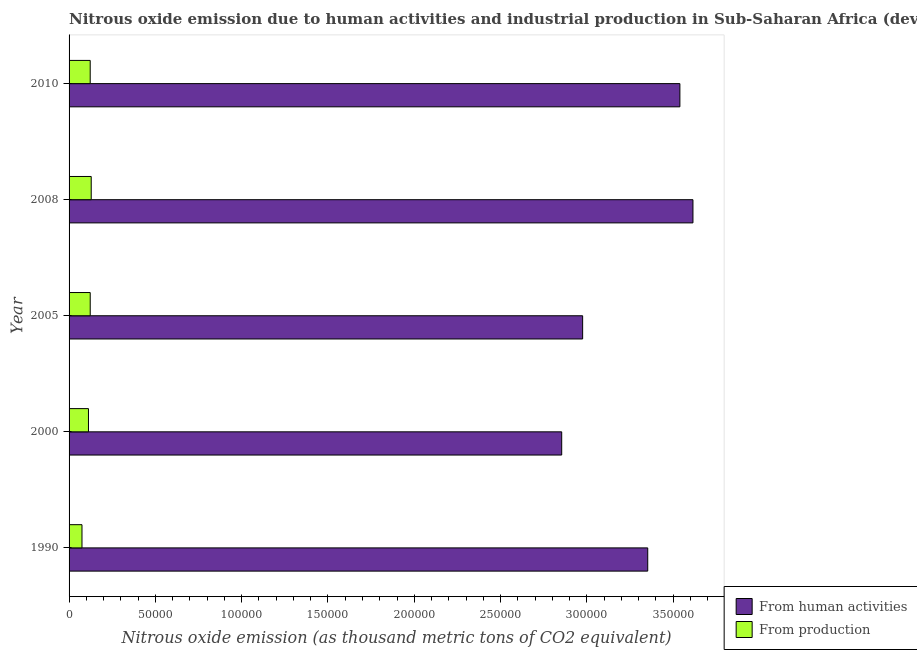Are the number of bars per tick equal to the number of legend labels?
Ensure brevity in your answer.  Yes. Are the number of bars on each tick of the Y-axis equal?
Your answer should be very brief. Yes. How many bars are there on the 5th tick from the bottom?
Your response must be concise. 2. What is the label of the 3rd group of bars from the top?
Offer a terse response. 2005. In how many cases, is the number of bars for a given year not equal to the number of legend labels?
Provide a succinct answer. 0. What is the amount of emissions generated from industries in 2005?
Keep it short and to the point. 1.23e+04. Across all years, what is the maximum amount of emissions generated from industries?
Your response must be concise. 1.28e+04. Across all years, what is the minimum amount of emissions generated from industries?
Your answer should be very brief. 7482.3. In which year was the amount of emissions from human activities maximum?
Give a very brief answer. 2008. What is the total amount of emissions from human activities in the graph?
Your answer should be very brief. 1.63e+06. What is the difference between the amount of emissions generated from industries in 2000 and that in 2008?
Provide a short and direct response. -1594.7. What is the difference between the amount of emissions from human activities in 2008 and the amount of emissions generated from industries in 1990?
Your response must be concise. 3.54e+05. What is the average amount of emissions from human activities per year?
Give a very brief answer. 3.27e+05. In the year 1990, what is the difference between the amount of emissions from human activities and amount of emissions generated from industries?
Your response must be concise. 3.28e+05. In how many years, is the amount of emissions from human activities greater than 250000 thousand metric tons?
Keep it short and to the point. 5. What is the ratio of the amount of emissions from human activities in 2000 to that in 2010?
Your answer should be compact. 0.81. Is the difference between the amount of emissions from human activities in 2000 and 2005 greater than the difference between the amount of emissions generated from industries in 2000 and 2005?
Provide a short and direct response. No. What is the difference between the highest and the second highest amount of emissions from human activities?
Offer a terse response. 7568.3. What is the difference between the highest and the lowest amount of emissions from human activities?
Your response must be concise. 7.60e+04. In how many years, is the amount of emissions from human activities greater than the average amount of emissions from human activities taken over all years?
Provide a short and direct response. 3. What does the 1st bar from the top in 2010 represents?
Keep it short and to the point. From production. What does the 2nd bar from the bottom in 2008 represents?
Your response must be concise. From production. Are the values on the major ticks of X-axis written in scientific E-notation?
Provide a succinct answer. No. Where does the legend appear in the graph?
Offer a very short reply. Bottom right. What is the title of the graph?
Provide a short and direct response. Nitrous oxide emission due to human activities and industrial production in Sub-Saharan Africa (developing only). What is the label or title of the X-axis?
Give a very brief answer. Nitrous oxide emission (as thousand metric tons of CO2 equivalent). What is the Nitrous oxide emission (as thousand metric tons of CO2 equivalent) of From human activities in 1990?
Provide a short and direct response. 3.35e+05. What is the Nitrous oxide emission (as thousand metric tons of CO2 equivalent) of From production in 1990?
Offer a terse response. 7482.3. What is the Nitrous oxide emission (as thousand metric tons of CO2 equivalent) in From human activities in 2000?
Keep it short and to the point. 2.85e+05. What is the Nitrous oxide emission (as thousand metric tons of CO2 equivalent) of From production in 2000?
Provide a short and direct response. 1.12e+04. What is the Nitrous oxide emission (as thousand metric tons of CO2 equivalent) in From human activities in 2005?
Your answer should be very brief. 2.98e+05. What is the Nitrous oxide emission (as thousand metric tons of CO2 equivalent) in From production in 2005?
Provide a short and direct response. 1.23e+04. What is the Nitrous oxide emission (as thousand metric tons of CO2 equivalent) of From human activities in 2008?
Offer a terse response. 3.61e+05. What is the Nitrous oxide emission (as thousand metric tons of CO2 equivalent) in From production in 2008?
Offer a terse response. 1.28e+04. What is the Nitrous oxide emission (as thousand metric tons of CO2 equivalent) in From human activities in 2010?
Offer a terse response. 3.54e+05. What is the Nitrous oxide emission (as thousand metric tons of CO2 equivalent) of From production in 2010?
Provide a succinct answer. 1.22e+04. Across all years, what is the maximum Nitrous oxide emission (as thousand metric tons of CO2 equivalent) in From human activities?
Ensure brevity in your answer.  3.61e+05. Across all years, what is the maximum Nitrous oxide emission (as thousand metric tons of CO2 equivalent) of From production?
Offer a very short reply. 1.28e+04. Across all years, what is the minimum Nitrous oxide emission (as thousand metric tons of CO2 equivalent) in From human activities?
Make the answer very short. 2.85e+05. Across all years, what is the minimum Nitrous oxide emission (as thousand metric tons of CO2 equivalent) in From production?
Keep it short and to the point. 7482.3. What is the total Nitrous oxide emission (as thousand metric tons of CO2 equivalent) of From human activities in the graph?
Your answer should be very brief. 1.63e+06. What is the total Nitrous oxide emission (as thousand metric tons of CO2 equivalent) of From production in the graph?
Give a very brief answer. 5.61e+04. What is the difference between the Nitrous oxide emission (as thousand metric tons of CO2 equivalent) in From human activities in 1990 and that in 2000?
Ensure brevity in your answer.  4.98e+04. What is the difference between the Nitrous oxide emission (as thousand metric tons of CO2 equivalent) of From production in 1990 and that in 2000?
Offer a very short reply. -3756.4. What is the difference between the Nitrous oxide emission (as thousand metric tons of CO2 equivalent) in From human activities in 1990 and that in 2005?
Give a very brief answer. 3.77e+04. What is the difference between the Nitrous oxide emission (as thousand metric tons of CO2 equivalent) of From production in 1990 and that in 2005?
Offer a very short reply. -4774.5. What is the difference between the Nitrous oxide emission (as thousand metric tons of CO2 equivalent) in From human activities in 1990 and that in 2008?
Your response must be concise. -2.62e+04. What is the difference between the Nitrous oxide emission (as thousand metric tons of CO2 equivalent) in From production in 1990 and that in 2008?
Keep it short and to the point. -5351.1. What is the difference between the Nitrous oxide emission (as thousand metric tons of CO2 equivalent) of From human activities in 1990 and that in 2010?
Offer a terse response. -1.86e+04. What is the difference between the Nitrous oxide emission (as thousand metric tons of CO2 equivalent) in From production in 1990 and that in 2010?
Your answer should be very brief. -4759.9. What is the difference between the Nitrous oxide emission (as thousand metric tons of CO2 equivalent) of From human activities in 2000 and that in 2005?
Your response must be concise. -1.21e+04. What is the difference between the Nitrous oxide emission (as thousand metric tons of CO2 equivalent) of From production in 2000 and that in 2005?
Ensure brevity in your answer.  -1018.1. What is the difference between the Nitrous oxide emission (as thousand metric tons of CO2 equivalent) of From human activities in 2000 and that in 2008?
Keep it short and to the point. -7.60e+04. What is the difference between the Nitrous oxide emission (as thousand metric tons of CO2 equivalent) in From production in 2000 and that in 2008?
Give a very brief answer. -1594.7. What is the difference between the Nitrous oxide emission (as thousand metric tons of CO2 equivalent) in From human activities in 2000 and that in 2010?
Make the answer very short. -6.85e+04. What is the difference between the Nitrous oxide emission (as thousand metric tons of CO2 equivalent) in From production in 2000 and that in 2010?
Provide a succinct answer. -1003.5. What is the difference between the Nitrous oxide emission (as thousand metric tons of CO2 equivalent) of From human activities in 2005 and that in 2008?
Your response must be concise. -6.39e+04. What is the difference between the Nitrous oxide emission (as thousand metric tons of CO2 equivalent) in From production in 2005 and that in 2008?
Provide a succinct answer. -576.6. What is the difference between the Nitrous oxide emission (as thousand metric tons of CO2 equivalent) in From human activities in 2005 and that in 2010?
Give a very brief answer. -5.63e+04. What is the difference between the Nitrous oxide emission (as thousand metric tons of CO2 equivalent) of From human activities in 2008 and that in 2010?
Provide a succinct answer. 7568.3. What is the difference between the Nitrous oxide emission (as thousand metric tons of CO2 equivalent) in From production in 2008 and that in 2010?
Your answer should be compact. 591.2. What is the difference between the Nitrous oxide emission (as thousand metric tons of CO2 equivalent) of From human activities in 1990 and the Nitrous oxide emission (as thousand metric tons of CO2 equivalent) of From production in 2000?
Offer a terse response. 3.24e+05. What is the difference between the Nitrous oxide emission (as thousand metric tons of CO2 equivalent) of From human activities in 1990 and the Nitrous oxide emission (as thousand metric tons of CO2 equivalent) of From production in 2005?
Give a very brief answer. 3.23e+05. What is the difference between the Nitrous oxide emission (as thousand metric tons of CO2 equivalent) of From human activities in 1990 and the Nitrous oxide emission (as thousand metric tons of CO2 equivalent) of From production in 2008?
Make the answer very short. 3.22e+05. What is the difference between the Nitrous oxide emission (as thousand metric tons of CO2 equivalent) in From human activities in 1990 and the Nitrous oxide emission (as thousand metric tons of CO2 equivalent) in From production in 2010?
Give a very brief answer. 3.23e+05. What is the difference between the Nitrous oxide emission (as thousand metric tons of CO2 equivalent) in From human activities in 2000 and the Nitrous oxide emission (as thousand metric tons of CO2 equivalent) in From production in 2005?
Your answer should be compact. 2.73e+05. What is the difference between the Nitrous oxide emission (as thousand metric tons of CO2 equivalent) in From human activities in 2000 and the Nitrous oxide emission (as thousand metric tons of CO2 equivalent) in From production in 2008?
Offer a terse response. 2.73e+05. What is the difference between the Nitrous oxide emission (as thousand metric tons of CO2 equivalent) of From human activities in 2000 and the Nitrous oxide emission (as thousand metric tons of CO2 equivalent) of From production in 2010?
Your response must be concise. 2.73e+05. What is the difference between the Nitrous oxide emission (as thousand metric tons of CO2 equivalent) in From human activities in 2005 and the Nitrous oxide emission (as thousand metric tons of CO2 equivalent) in From production in 2008?
Offer a terse response. 2.85e+05. What is the difference between the Nitrous oxide emission (as thousand metric tons of CO2 equivalent) in From human activities in 2005 and the Nitrous oxide emission (as thousand metric tons of CO2 equivalent) in From production in 2010?
Your response must be concise. 2.85e+05. What is the difference between the Nitrous oxide emission (as thousand metric tons of CO2 equivalent) of From human activities in 2008 and the Nitrous oxide emission (as thousand metric tons of CO2 equivalent) of From production in 2010?
Provide a succinct answer. 3.49e+05. What is the average Nitrous oxide emission (as thousand metric tons of CO2 equivalent) of From human activities per year?
Your answer should be very brief. 3.27e+05. What is the average Nitrous oxide emission (as thousand metric tons of CO2 equivalent) of From production per year?
Make the answer very short. 1.12e+04. In the year 1990, what is the difference between the Nitrous oxide emission (as thousand metric tons of CO2 equivalent) in From human activities and Nitrous oxide emission (as thousand metric tons of CO2 equivalent) in From production?
Offer a terse response. 3.28e+05. In the year 2000, what is the difference between the Nitrous oxide emission (as thousand metric tons of CO2 equivalent) in From human activities and Nitrous oxide emission (as thousand metric tons of CO2 equivalent) in From production?
Provide a succinct answer. 2.74e+05. In the year 2005, what is the difference between the Nitrous oxide emission (as thousand metric tons of CO2 equivalent) of From human activities and Nitrous oxide emission (as thousand metric tons of CO2 equivalent) of From production?
Your answer should be compact. 2.85e+05. In the year 2008, what is the difference between the Nitrous oxide emission (as thousand metric tons of CO2 equivalent) of From human activities and Nitrous oxide emission (as thousand metric tons of CO2 equivalent) of From production?
Give a very brief answer. 3.49e+05. In the year 2010, what is the difference between the Nitrous oxide emission (as thousand metric tons of CO2 equivalent) of From human activities and Nitrous oxide emission (as thousand metric tons of CO2 equivalent) of From production?
Provide a succinct answer. 3.42e+05. What is the ratio of the Nitrous oxide emission (as thousand metric tons of CO2 equivalent) in From human activities in 1990 to that in 2000?
Offer a terse response. 1.17. What is the ratio of the Nitrous oxide emission (as thousand metric tons of CO2 equivalent) of From production in 1990 to that in 2000?
Keep it short and to the point. 0.67. What is the ratio of the Nitrous oxide emission (as thousand metric tons of CO2 equivalent) in From human activities in 1990 to that in 2005?
Offer a very short reply. 1.13. What is the ratio of the Nitrous oxide emission (as thousand metric tons of CO2 equivalent) of From production in 1990 to that in 2005?
Offer a terse response. 0.61. What is the ratio of the Nitrous oxide emission (as thousand metric tons of CO2 equivalent) in From human activities in 1990 to that in 2008?
Your response must be concise. 0.93. What is the ratio of the Nitrous oxide emission (as thousand metric tons of CO2 equivalent) of From production in 1990 to that in 2008?
Your answer should be very brief. 0.58. What is the ratio of the Nitrous oxide emission (as thousand metric tons of CO2 equivalent) in From human activities in 1990 to that in 2010?
Ensure brevity in your answer.  0.95. What is the ratio of the Nitrous oxide emission (as thousand metric tons of CO2 equivalent) in From production in 1990 to that in 2010?
Offer a very short reply. 0.61. What is the ratio of the Nitrous oxide emission (as thousand metric tons of CO2 equivalent) of From human activities in 2000 to that in 2005?
Provide a short and direct response. 0.96. What is the ratio of the Nitrous oxide emission (as thousand metric tons of CO2 equivalent) of From production in 2000 to that in 2005?
Provide a succinct answer. 0.92. What is the ratio of the Nitrous oxide emission (as thousand metric tons of CO2 equivalent) of From human activities in 2000 to that in 2008?
Your response must be concise. 0.79. What is the ratio of the Nitrous oxide emission (as thousand metric tons of CO2 equivalent) in From production in 2000 to that in 2008?
Provide a short and direct response. 0.88. What is the ratio of the Nitrous oxide emission (as thousand metric tons of CO2 equivalent) in From human activities in 2000 to that in 2010?
Give a very brief answer. 0.81. What is the ratio of the Nitrous oxide emission (as thousand metric tons of CO2 equivalent) in From production in 2000 to that in 2010?
Offer a very short reply. 0.92. What is the ratio of the Nitrous oxide emission (as thousand metric tons of CO2 equivalent) of From human activities in 2005 to that in 2008?
Provide a succinct answer. 0.82. What is the ratio of the Nitrous oxide emission (as thousand metric tons of CO2 equivalent) in From production in 2005 to that in 2008?
Provide a short and direct response. 0.96. What is the ratio of the Nitrous oxide emission (as thousand metric tons of CO2 equivalent) of From human activities in 2005 to that in 2010?
Your response must be concise. 0.84. What is the ratio of the Nitrous oxide emission (as thousand metric tons of CO2 equivalent) of From production in 2005 to that in 2010?
Ensure brevity in your answer.  1. What is the ratio of the Nitrous oxide emission (as thousand metric tons of CO2 equivalent) in From human activities in 2008 to that in 2010?
Offer a terse response. 1.02. What is the ratio of the Nitrous oxide emission (as thousand metric tons of CO2 equivalent) in From production in 2008 to that in 2010?
Your answer should be very brief. 1.05. What is the difference between the highest and the second highest Nitrous oxide emission (as thousand metric tons of CO2 equivalent) in From human activities?
Offer a very short reply. 7568.3. What is the difference between the highest and the second highest Nitrous oxide emission (as thousand metric tons of CO2 equivalent) of From production?
Your answer should be very brief. 576.6. What is the difference between the highest and the lowest Nitrous oxide emission (as thousand metric tons of CO2 equivalent) in From human activities?
Provide a succinct answer. 7.60e+04. What is the difference between the highest and the lowest Nitrous oxide emission (as thousand metric tons of CO2 equivalent) of From production?
Your answer should be compact. 5351.1. 